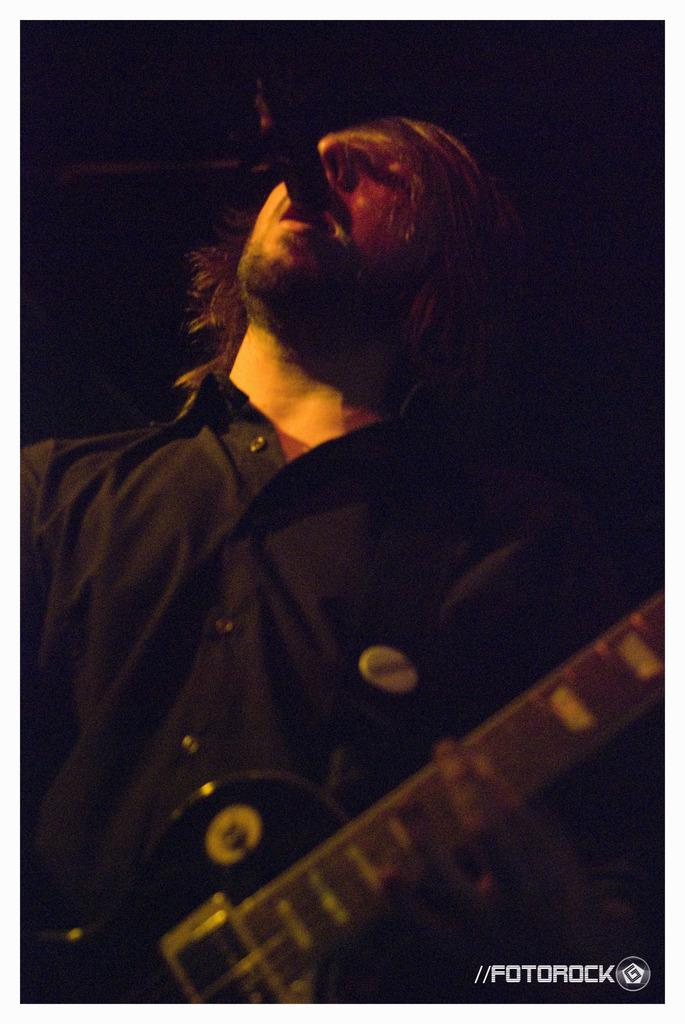What is the main subject of the image? There is a person in the image. What is the person wearing? The person is wearing a black dress. What is the person holding in the image? The person is holding a musical instrument. What can be seen behind the person? The person is standing in front of a mic. What is the color of the background in the image? The background of the image is black. What type of ink can be seen spilling on the floor in the image? There is no ink spilling on the floor in the image. How many cars are parked behind the person in the image? There are no cars visible in the image. 